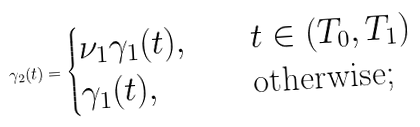Convert formula to latex. <formula><loc_0><loc_0><loc_500><loc_500>\gamma _ { 2 } ( t ) = \begin{cases} \nu _ { 1 } \gamma _ { 1 } ( t ) , \quad & t \in ( T _ { 0 } , T _ { 1 } ) \\ \gamma _ { 1 } ( t ) , & \text {otherwise;} \end{cases}</formula> 